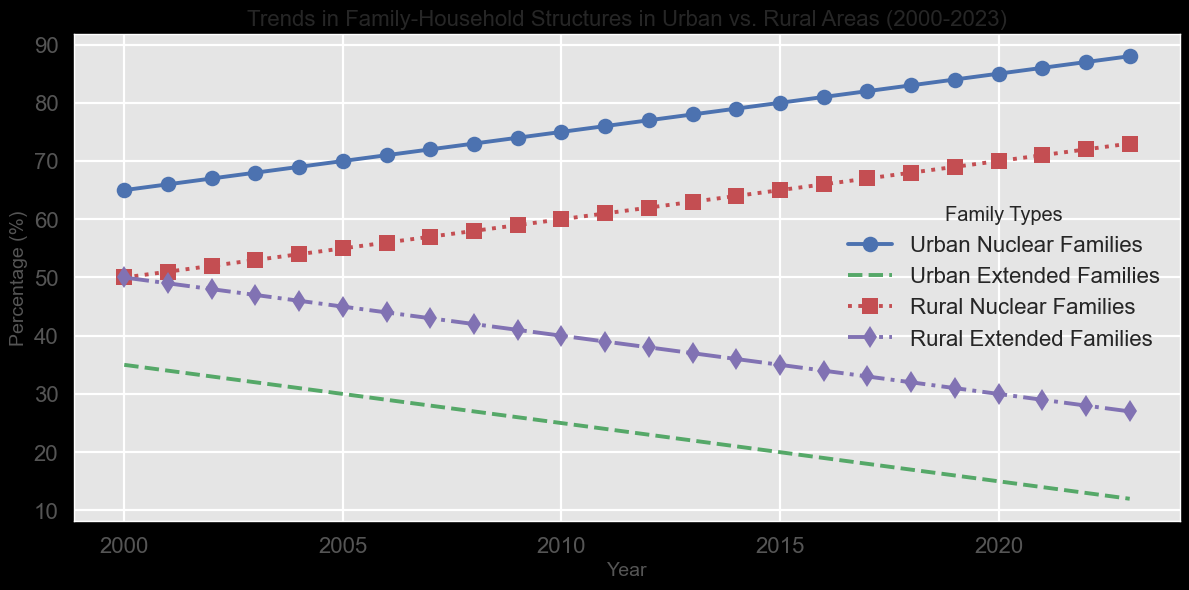What was the percentage of Urban Nuclear Families in 2000? The first data point for Urban Nuclear Families is in the year 2000, and from the graph, this value is represented by the blue line at the 65% mark.
Answer: 65% How do the trends of Urban Nuclear Families and Rural Nuclear Families compare over time? Both Urban Nuclear Families (blue line) and Rural Nuclear Families (red line) show an increasing trend. However, Urban Nuclear Families increase more rapidly, starting from 65% in 2000 and reaching 88% in 2023, compared to Rural Nuclear Families, which start at 50% and rise to 73% in the same period.
Answer: Urban: 65% to 88%, Rural: 50% to 73% What is the difference in percentage between Urban Extended Families in 2000 and 2023? In 2000, Urban Extended Families are at 35% (green dashed line), and in 2023, they are at 12%. The difference is calculated as 35 - 12.
Answer: 23% Which type of family experienced the most significant increase in percentage from 2000 to 2023? Checking the changes for each family type: Urban Nuclear Families (65% to 88%), Urban Extended Families (35% to 12%), Rural Nuclear Families (50% to 73%), and Rural Extended Families (50% to 27%). The most significant increase is 88 - 65 = 23.
Answer: Urban Nuclear Families What's the average percentage of Rural Extended Families between 2000 and 2023? Sum the percentages of Rural Extended Families for all years from 2000 to 2023 and divide by the number of years (24). The sum is 50 + 49 + 48 + ... + 28 + 27.
Answer: 38.5% In which year did Urban Nuclear Families and Rural Nuclear Families both share the same percentage? Observe the year when both the blue line (Urban Nuclear Families) and the red line (Rural Nuclear Families) intersect or share the same value. This does not happen in the data provided.
Answer: Never Between 2000 and 2023, which family type in Urban areas experienced the least change in percentage? Urban Nuclear Families changed from 65% to 88%, a change of 23%. Urban Extended Families changed from 35% to 12%, a change of 23%. Both changes are the same.
Answer: Urban Nuclear and Urban Extended, both with 23% change How did the composition of Rural Extended Families change between the beginning and end of the given period? Rural Extended Families remained stable at 50% in 2000 and gradually decreased to 27% in 2023, marking a decrease of 23 percentage points.
Answer: Decreased from 50% to 27% Which family type in Rural areas showed an increase over the years, and by how much? Rural Nuclear Families increased from 50% in 2000 to 73% in 2023. The change is 73 - 50.
Answer: Increased by 23% 